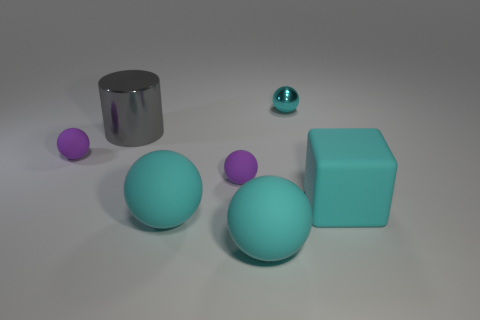How many cyan spheres must be subtracted to get 1 cyan spheres? 2 Subtract all tiny purple rubber spheres. How many spheres are left? 3 Subtract all purple spheres. How many spheres are left? 3 Subtract all cylinders. How many objects are left? 6 Subtract 4 spheres. How many spheres are left? 1 Add 1 brown spheres. How many objects exist? 8 Subtract 0 purple cylinders. How many objects are left? 7 Subtract all purple balls. Subtract all green blocks. How many balls are left? 3 Subtract all blue cylinders. How many yellow spheres are left? 0 Subtract all big gray metal cylinders. Subtract all large cyan cubes. How many objects are left? 5 